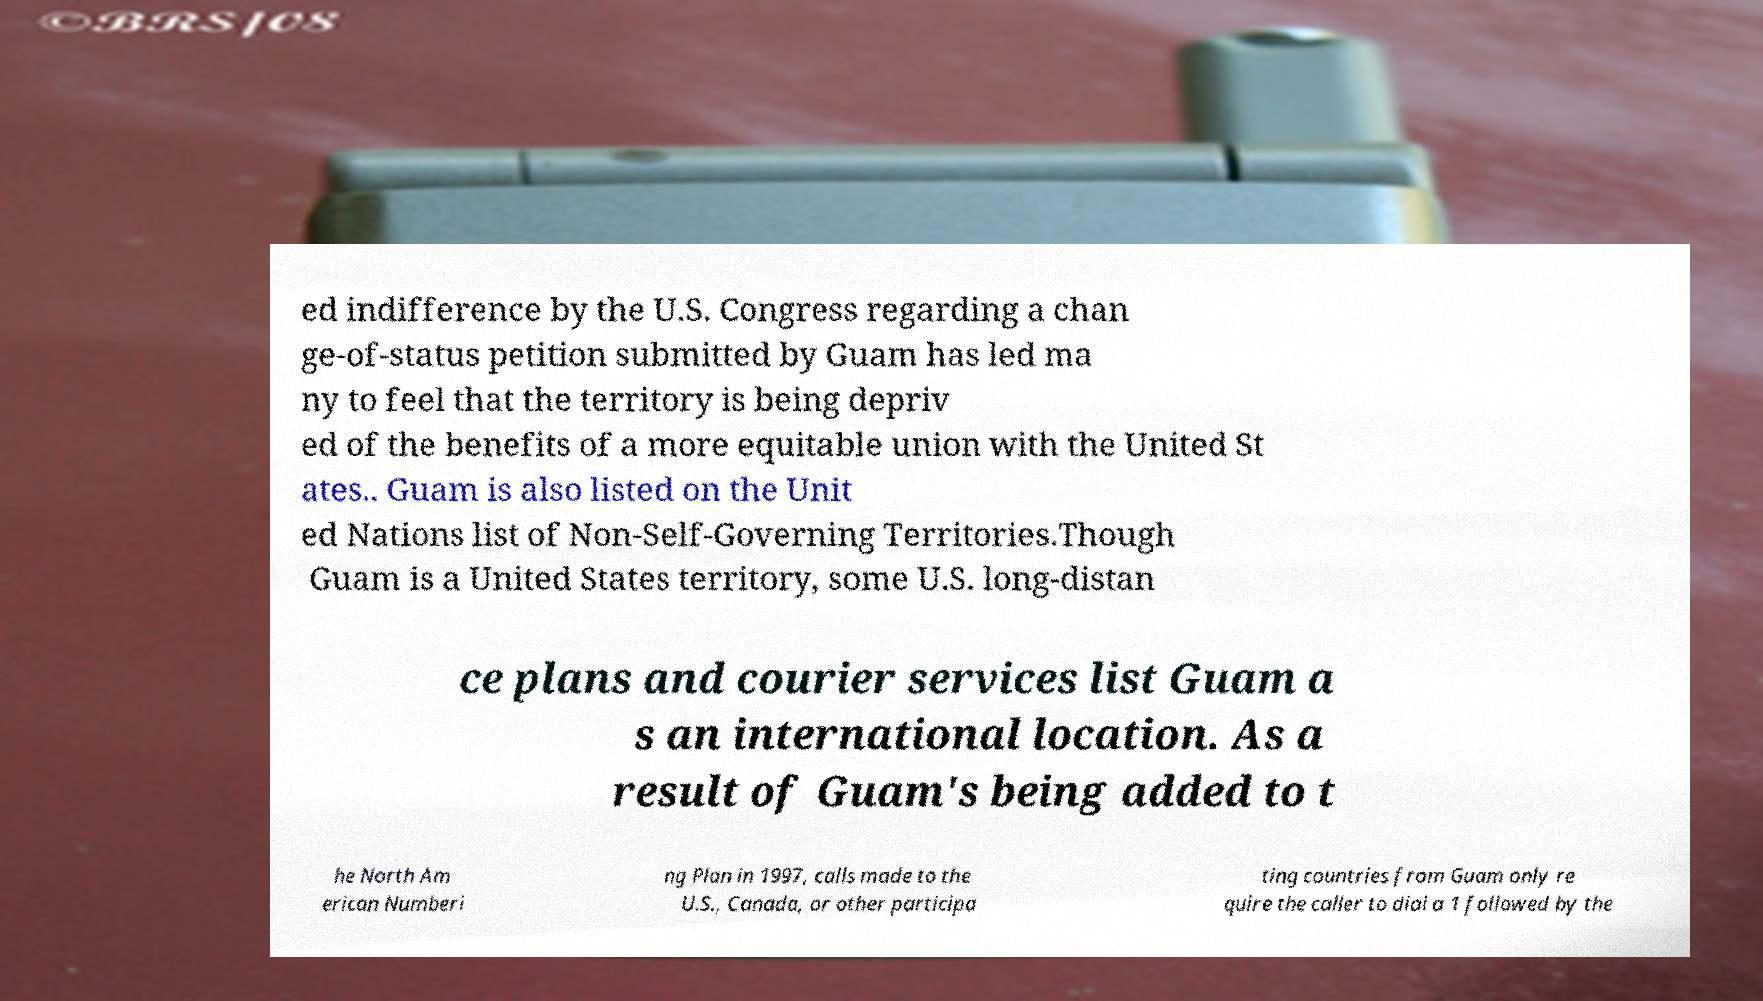Please identify and transcribe the text found in this image. ed indifference by the U.S. Congress regarding a chan ge-of-status petition submitted by Guam has led ma ny to feel that the territory is being depriv ed of the benefits of a more equitable union with the United St ates.. Guam is also listed on the Unit ed Nations list of Non-Self-Governing Territories.Though Guam is a United States territory, some U.S. long-distan ce plans and courier services list Guam a s an international location. As a result of Guam's being added to t he North Am erican Numberi ng Plan in 1997, calls made to the U.S., Canada, or other participa ting countries from Guam only re quire the caller to dial a 1 followed by the 